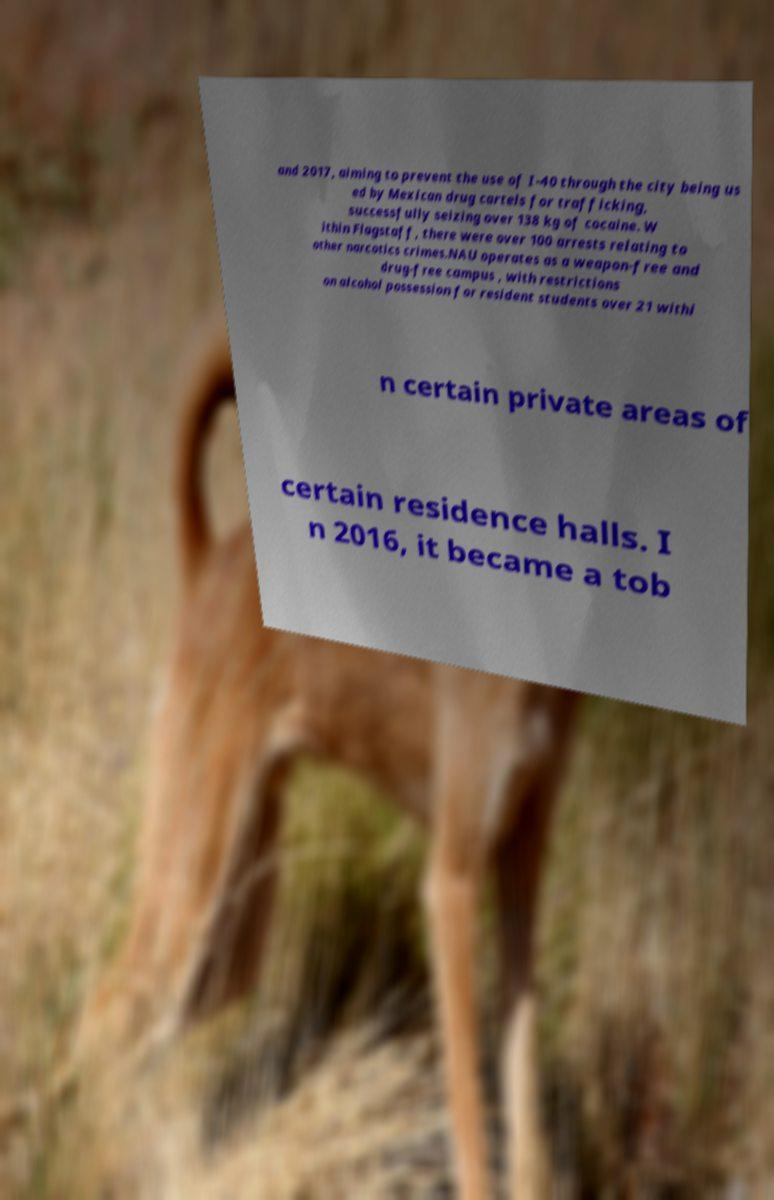What messages or text are displayed in this image? I need them in a readable, typed format. and 2017, aiming to prevent the use of I-40 through the city being us ed by Mexican drug cartels for trafficking, successfully seizing over 138 kg of cocaine. W ithin Flagstaff, there were over 100 arrests relating to other narcotics crimes.NAU operates as a weapon-free and drug-free campus , with restrictions on alcohol possession for resident students over 21 withi n certain private areas of certain residence halls. I n 2016, it became a tob 